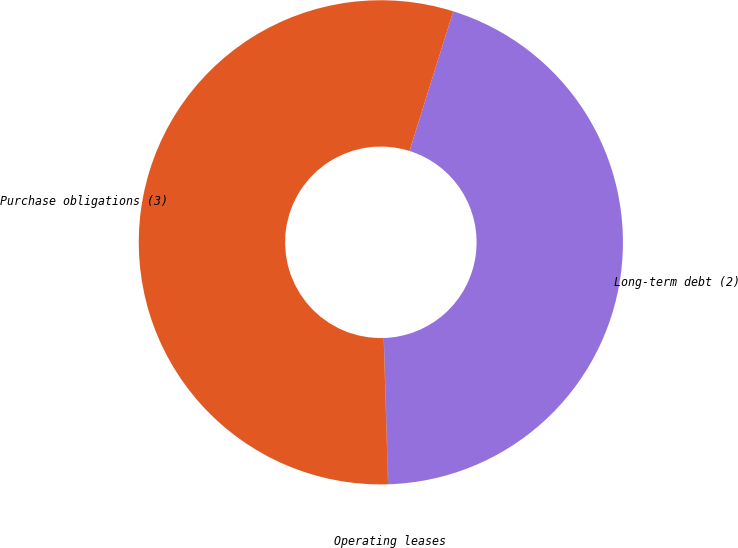Convert chart to OTSL. <chart><loc_0><loc_0><loc_500><loc_500><pie_chart><fcel>Long-term debt (2)<fcel>Operating leases<fcel>Purchase obligations (3)<nl><fcel>44.66%<fcel>0.03%<fcel>55.31%<nl></chart> 